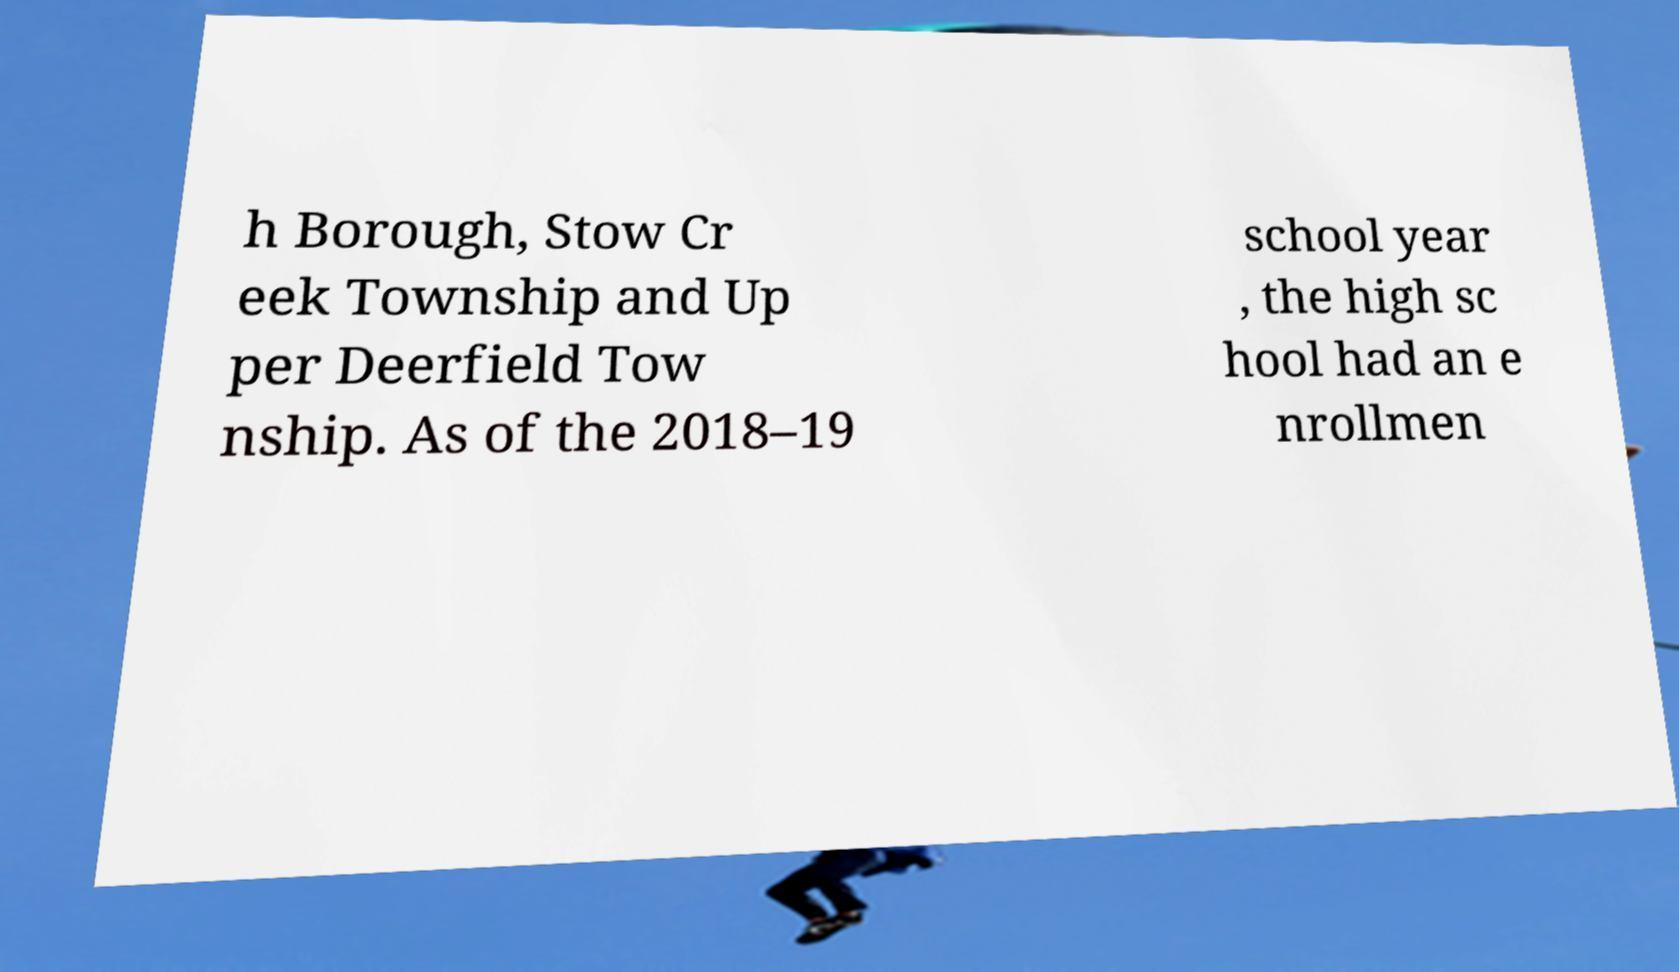Please read and relay the text visible in this image. What does it say? h Borough, Stow Cr eek Township and Up per Deerfield Tow nship. As of the 2018–19 school year , the high sc hool had an e nrollmen 